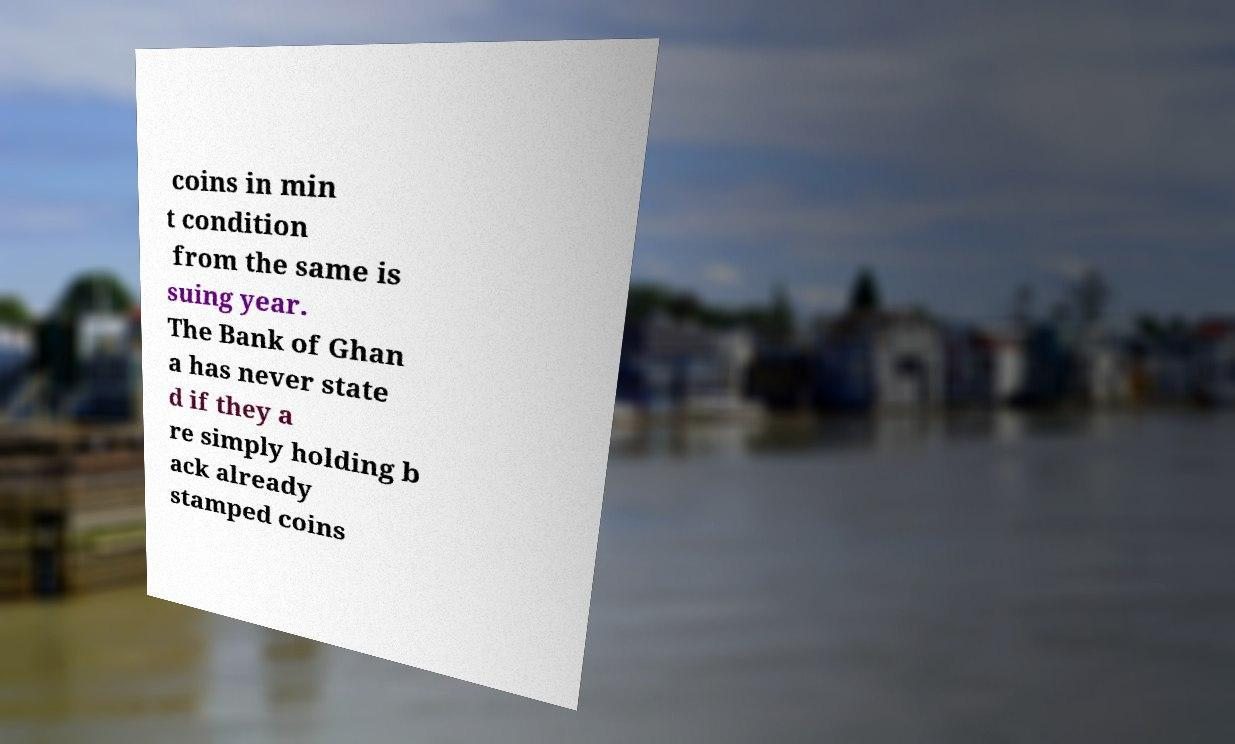Could you extract and type out the text from this image? coins in min t condition from the same is suing year. The Bank of Ghan a has never state d if they a re simply holding b ack already stamped coins 